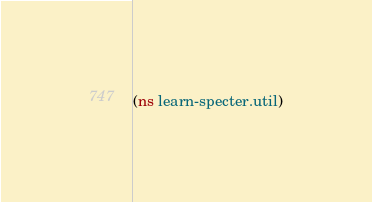<code> <loc_0><loc_0><loc_500><loc_500><_Clojure_>(ns learn-specter.util)


</code> 